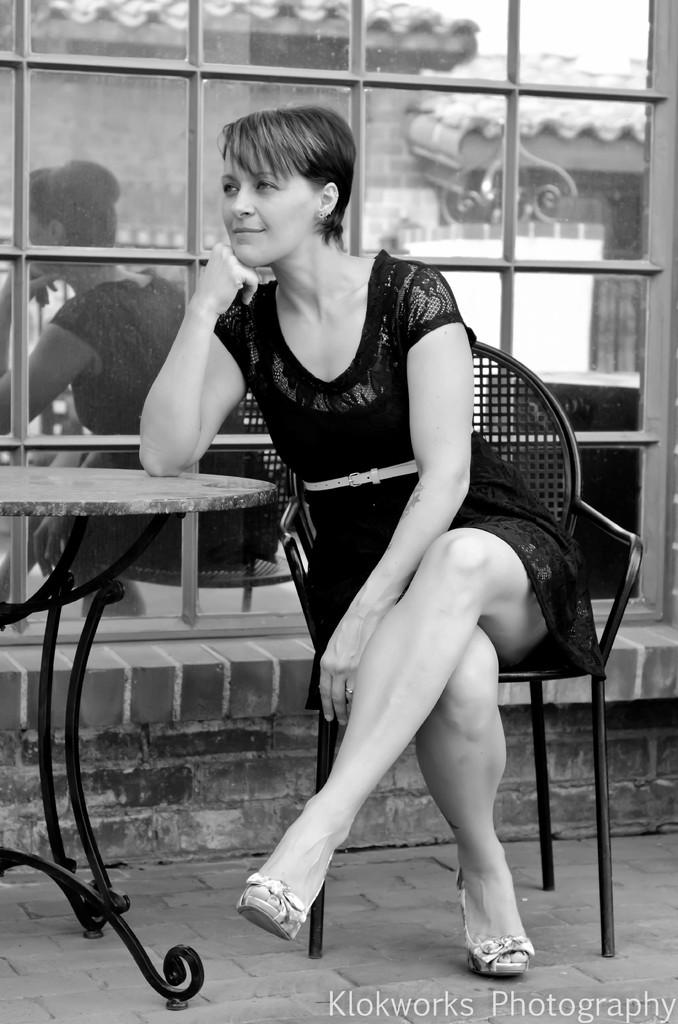Who is present in the image? There is a woman in the image. What is the woman doing in the image? The woman is sitting in a chair. Where is the chair located in relation to other objects? The chair is near a table. What can be seen in the background of the image? There is a building in the background of the image. How many jellyfish are swimming in the background of the image? There are no jellyfish present in the image; it features a woman sitting in a chair near a table with a building in the background. 